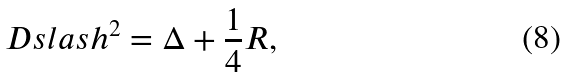Convert formula to latex. <formula><loc_0><loc_0><loc_500><loc_500>\ D s l a s h ^ { 2 } = \Delta + \frac { 1 } { 4 } R ,</formula> 